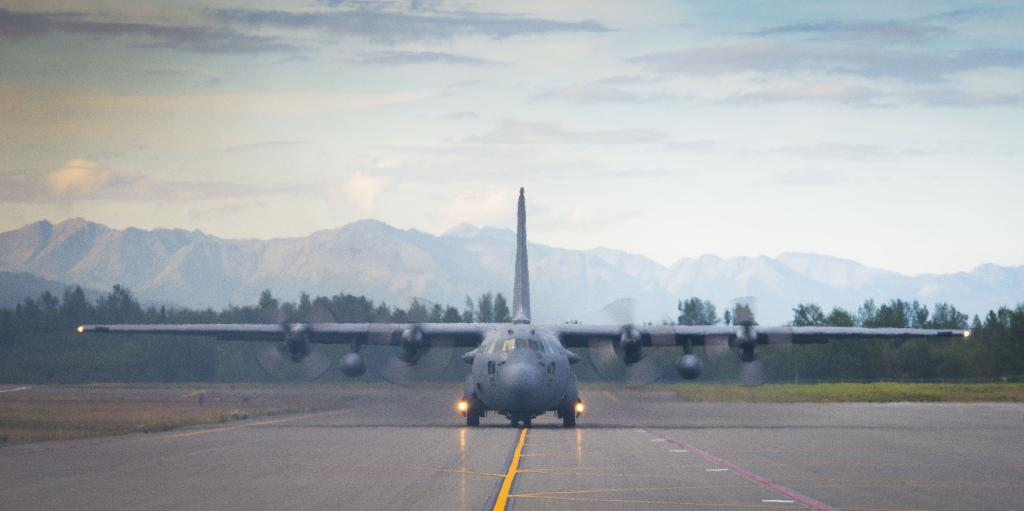What is located on the floor in the image? There is a flight visible on the floor. What type of landscape feature can be seen in the image? There is a hill in the image. What type of vegetation is present in the image? There are trees in the image. What is visible at the top of the image? The sky is visible at the top of the image. What type of competition is taking place on the hill in the image? There is no competition present in the image; it only features a hill, trees, and the sky. What kind of paper can be seen being used by the trees in the image? There is no paper present in the image; it only features a hill, trees, and the sky. 